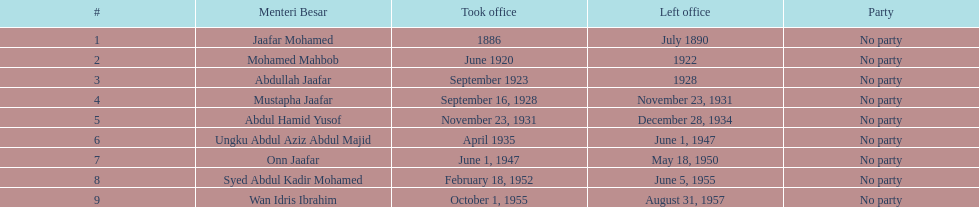Who dedicates the most hours in the office? Ungku Abdul Aziz Abdul Majid. 